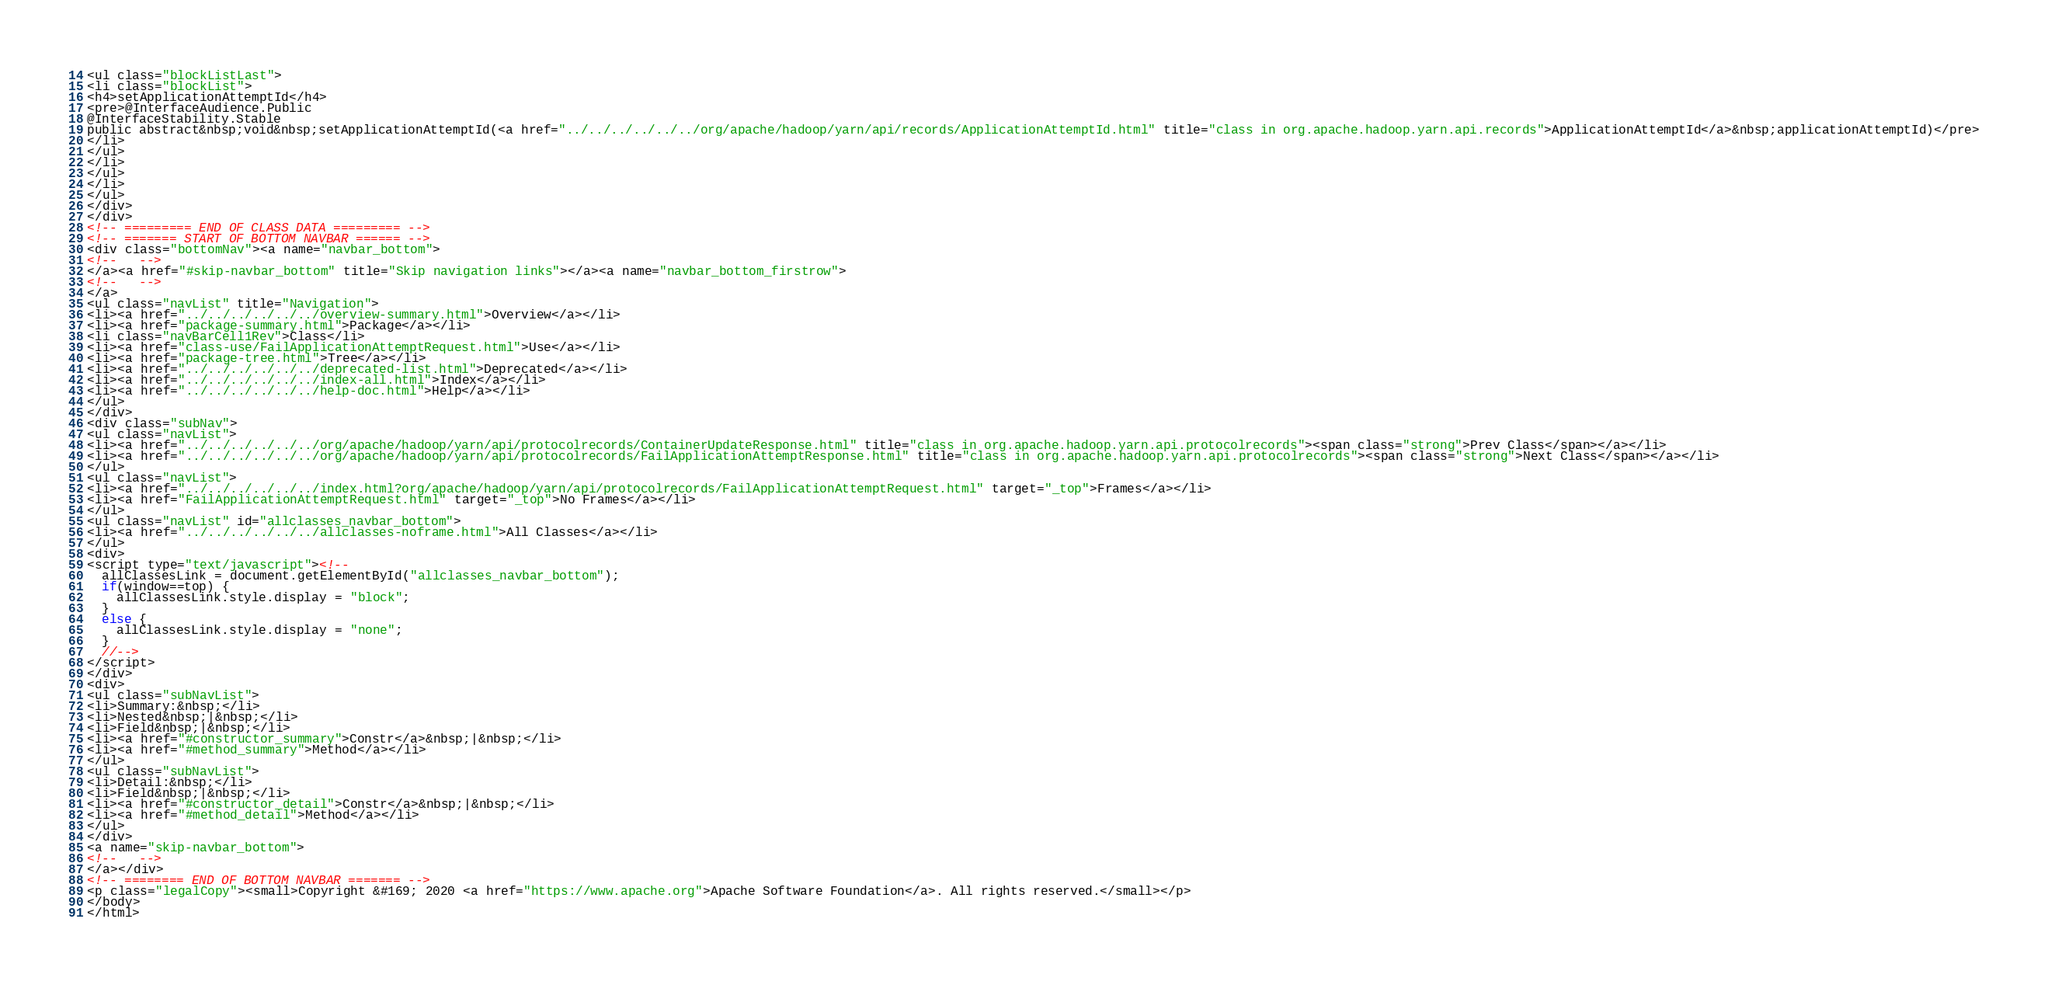Convert code to text. <code><loc_0><loc_0><loc_500><loc_500><_HTML_><ul class="blockListLast">
<li class="blockList">
<h4>setApplicationAttemptId</h4>
<pre>@InterfaceAudience.Public
@InterfaceStability.Stable
public abstract&nbsp;void&nbsp;setApplicationAttemptId(<a href="../../../../../../org/apache/hadoop/yarn/api/records/ApplicationAttemptId.html" title="class in org.apache.hadoop.yarn.api.records">ApplicationAttemptId</a>&nbsp;applicationAttemptId)</pre>
</li>
</ul>
</li>
</ul>
</li>
</ul>
</div>
</div>
<!-- ========= END OF CLASS DATA ========= -->
<!-- ======= START OF BOTTOM NAVBAR ====== -->
<div class="bottomNav"><a name="navbar_bottom">
<!--   -->
</a><a href="#skip-navbar_bottom" title="Skip navigation links"></a><a name="navbar_bottom_firstrow">
<!--   -->
</a>
<ul class="navList" title="Navigation">
<li><a href="../../../../../../overview-summary.html">Overview</a></li>
<li><a href="package-summary.html">Package</a></li>
<li class="navBarCell1Rev">Class</li>
<li><a href="class-use/FailApplicationAttemptRequest.html">Use</a></li>
<li><a href="package-tree.html">Tree</a></li>
<li><a href="../../../../../../deprecated-list.html">Deprecated</a></li>
<li><a href="../../../../../../index-all.html">Index</a></li>
<li><a href="../../../../../../help-doc.html">Help</a></li>
</ul>
</div>
<div class="subNav">
<ul class="navList">
<li><a href="../../../../../../org/apache/hadoop/yarn/api/protocolrecords/ContainerUpdateResponse.html" title="class in org.apache.hadoop.yarn.api.protocolrecords"><span class="strong">Prev Class</span></a></li>
<li><a href="../../../../../../org/apache/hadoop/yarn/api/protocolrecords/FailApplicationAttemptResponse.html" title="class in org.apache.hadoop.yarn.api.protocolrecords"><span class="strong">Next Class</span></a></li>
</ul>
<ul class="navList">
<li><a href="../../../../../../index.html?org/apache/hadoop/yarn/api/protocolrecords/FailApplicationAttemptRequest.html" target="_top">Frames</a></li>
<li><a href="FailApplicationAttemptRequest.html" target="_top">No Frames</a></li>
</ul>
<ul class="navList" id="allclasses_navbar_bottom">
<li><a href="../../../../../../allclasses-noframe.html">All Classes</a></li>
</ul>
<div>
<script type="text/javascript"><!--
  allClassesLink = document.getElementById("allclasses_navbar_bottom");
  if(window==top) {
    allClassesLink.style.display = "block";
  }
  else {
    allClassesLink.style.display = "none";
  }
  //-->
</script>
</div>
<div>
<ul class="subNavList">
<li>Summary:&nbsp;</li>
<li>Nested&nbsp;|&nbsp;</li>
<li>Field&nbsp;|&nbsp;</li>
<li><a href="#constructor_summary">Constr</a>&nbsp;|&nbsp;</li>
<li><a href="#method_summary">Method</a></li>
</ul>
<ul class="subNavList">
<li>Detail:&nbsp;</li>
<li>Field&nbsp;|&nbsp;</li>
<li><a href="#constructor_detail">Constr</a>&nbsp;|&nbsp;</li>
<li><a href="#method_detail">Method</a></li>
</ul>
</div>
<a name="skip-navbar_bottom">
<!--   -->
</a></div>
<!-- ======== END OF BOTTOM NAVBAR ======= -->
<p class="legalCopy"><small>Copyright &#169; 2020 <a href="https://www.apache.org">Apache Software Foundation</a>. All rights reserved.</small></p>
</body>
</html>
</code> 